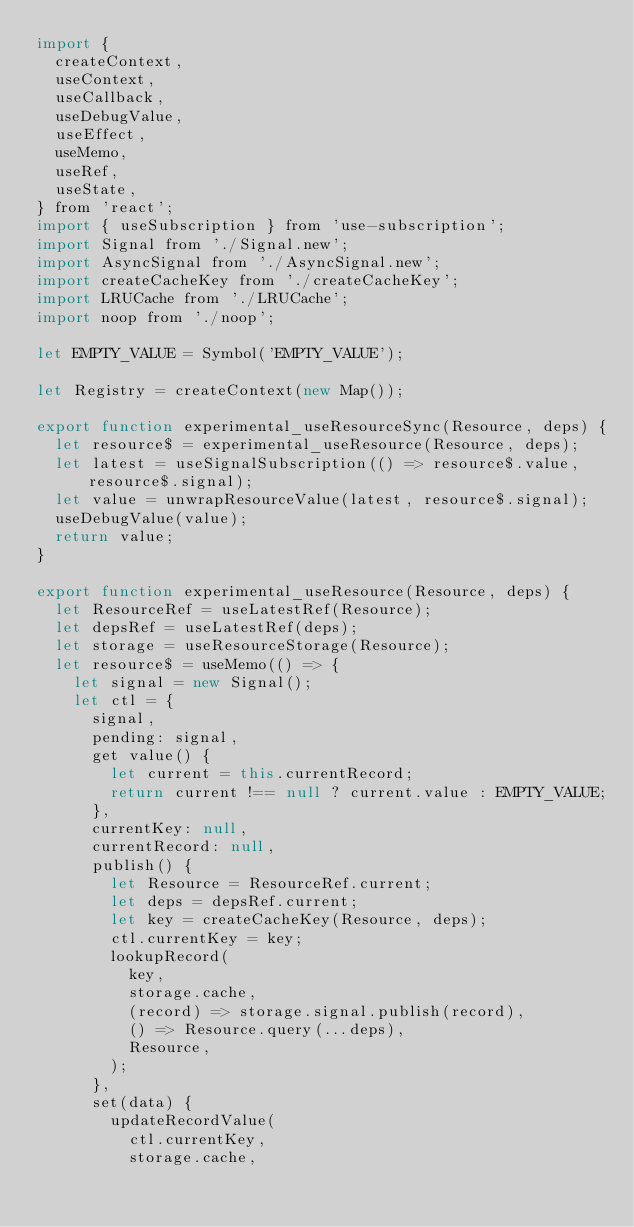<code> <loc_0><loc_0><loc_500><loc_500><_JavaScript_>import {
  createContext,
  useContext,
  useCallback,
  useDebugValue,
  useEffect,
  useMemo,
  useRef,
  useState,
} from 'react';
import { useSubscription } from 'use-subscription';
import Signal from './Signal.new';
import AsyncSignal from './AsyncSignal.new';
import createCacheKey from './createCacheKey';
import LRUCache from './LRUCache';
import noop from './noop';

let EMPTY_VALUE = Symbol('EMPTY_VALUE');

let Registry = createContext(new Map());

export function experimental_useResourceSync(Resource, deps) {
  let resource$ = experimental_useResource(Resource, deps);
  let latest = useSignalSubscription(() => resource$.value, resource$.signal);
  let value = unwrapResourceValue(latest, resource$.signal);
  useDebugValue(value);
  return value;
}

export function experimental_useResource(Resource, deps) {
  let ResourceRef = useLatestRef(Resource);
  let depsRef = useLatestRef(deps);
  let storage = useResourceStorage(Resource);
  let resource$ = useMemo(() => {
    let signal = new Signal();
    let ctl = {
      signal,
      pending: signal,
      get value() {
        let current = this.currentRecord;
        return current !== null ? current.value : EMPTY_VALUE;
      },
      currentKey: null,
      currentRecord: null,
      publish() {
        let Resource = ResourceRef.current;
        let deps = depsRef.current;
        let key = createCacheKey(Resource, deps);
        ctl.currentKey = key;
        lookupRecord(
          key,
          storage.cache,
          (record) => storage.signal.publish(record),
          () => Resource.query(...deps),
          Resource,
        );
      },
      set(data) {
        updateRecordValue(
          ctl.currentKey,
          storage.cache,</code> 